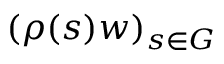Convert formula to latex. <formula><loc_0><loc_0><loc_500><loc_500>( \rho ( s ) w ) _ { s \in G }</formula> 